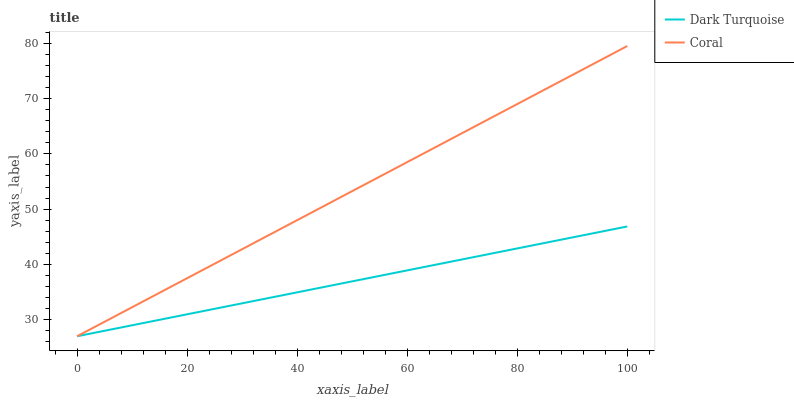Does Coral have the minimum area under the curve?
Answer yes or no. No. Is Coral the roughest?
Answer yes or no. No. 